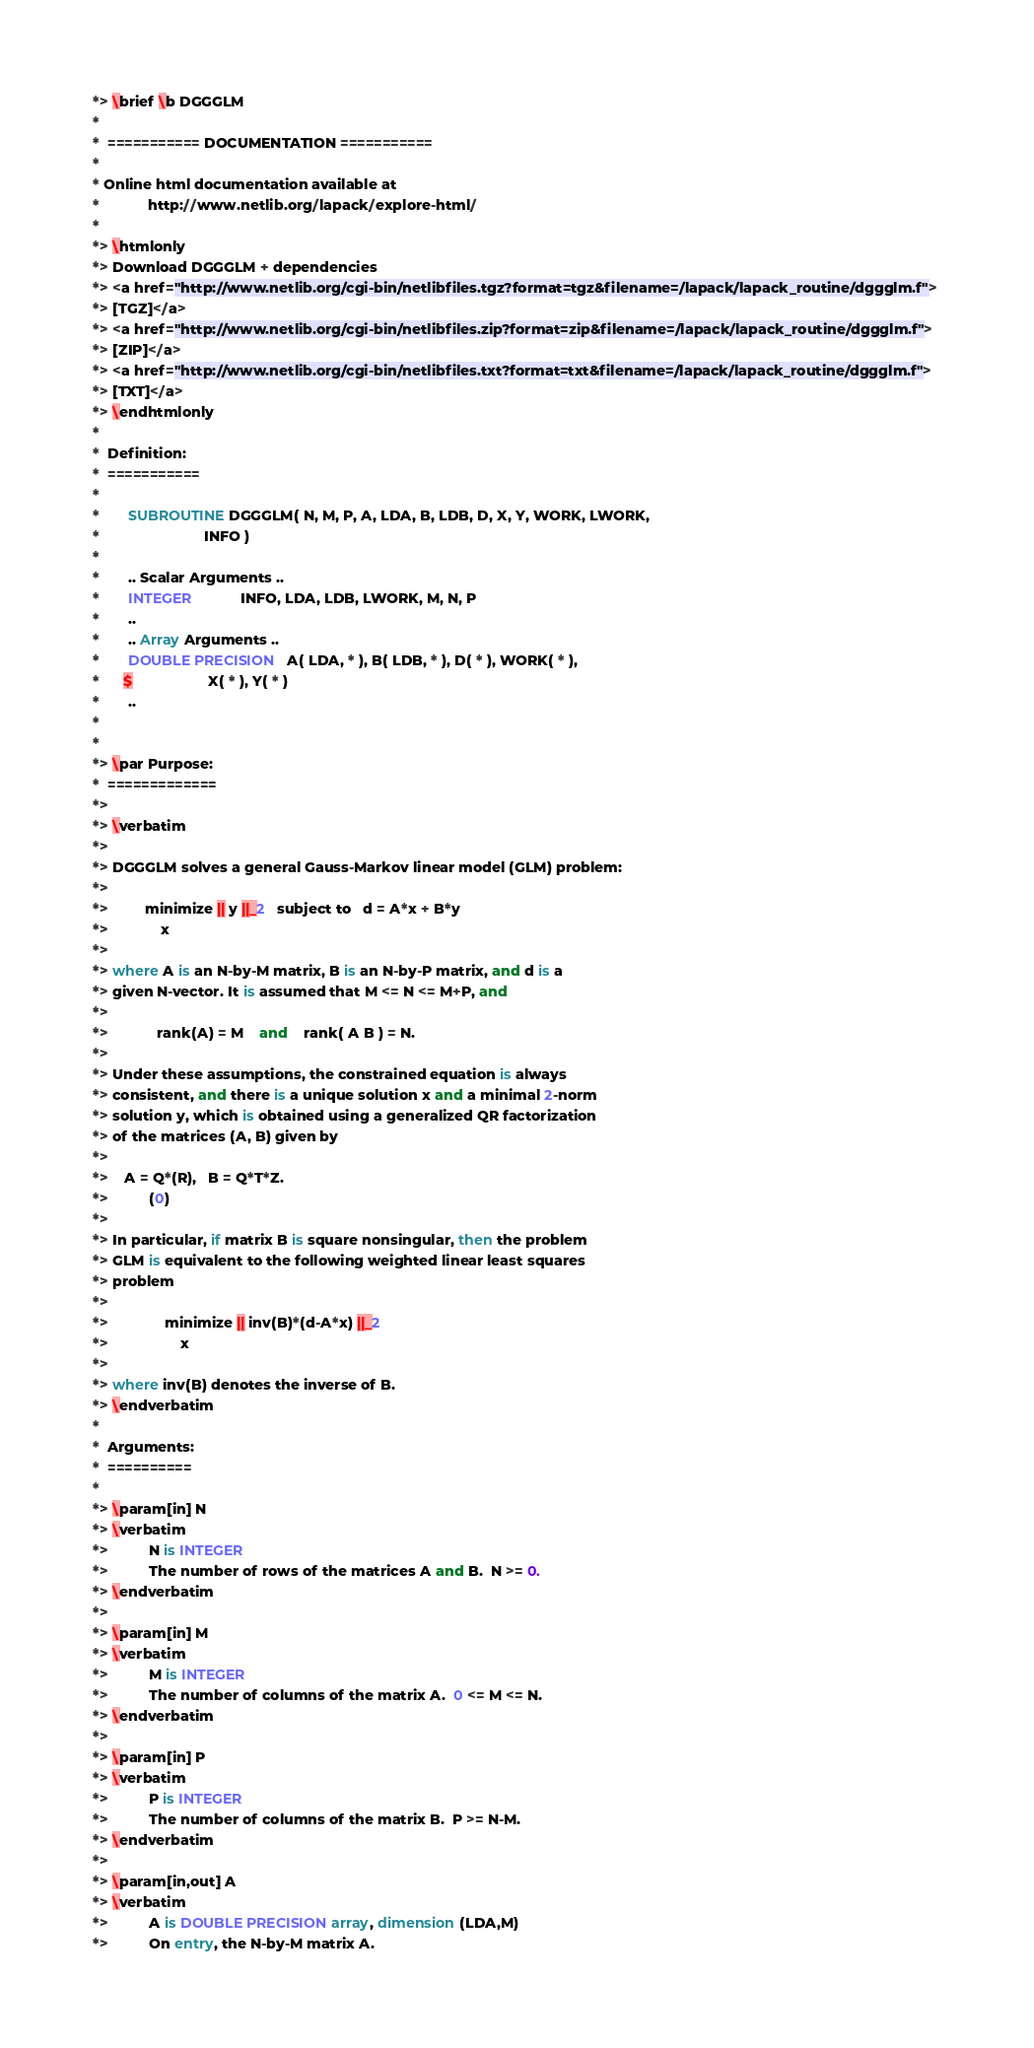<code> <loc_0><loc_0><loc_500><loc_500><_FORTRAN_>*> \brief \b DGGGLM
*
*  =========== DOCUMENTATION ===========
*
* Online html documentation available at 
*            http://www.netlib.org/lapack/explore-html/ 
*
*> \htmlonly
*> Download DGGGLM + dependencies 
*> <a href="http://www.netlib.org/cgi-bin/netlibfiles.tgz?format=tgz&filename=/lapack/lapack_routine/dggglm.f"> 
*> [TGZ]</a> 
*> <a href="http://www.netlib.org/cgi-bin/netlibfiles.zip?format=zip&filename=/lapack/lapack_routine/dggglm.f"> 
*> [ZIP]</a> 
*> <a href="http://www.netlib.org/cgi-bin/netlibfiles.txt?format=txt&filename=/lapack/lapack_routine/dggglm.f"> 
*> [TXT]</a>
*> \endhtmlonly 
*
*  Definition:
*  ===========
*
*       SUBROUTINE DGGGLM( N, M, P, A, LDA, B, LDB, D, X, Y, WORK, LWORK,
*                          INFO )
* 
*       .. Scalar Arguments ..
*       INTEGER            INFO, LDA, LDB, LWORK, M, N, P
*       ..
*       .. Array Arguments ..
*       DOUBLE PRECISION   A( LDA, * ), B( LDB, * ), D( * ), WORK( * ),
*      $                   X( * ), Y( * )
*       ..
*  
*
*> \par Purpose:
*  =============
*>
*> \verbatim
*>
*> DGGGLM solves a general Gauss-Markov linear model (GLM) problem:
*>
*>         minimize || y ||_2   subject to   d = A*x + B*y
*>             x
*>
*> where A is an N-by-M matrix, B is an N-by-P matrix, and d is a
*> given N-vector. It is assumed that M <= N <= M+P, and
*>
*>            rank(A) = M    and    rank( A B ) = N.
*>
*> Under these assumptions, the constrained equation is always
*> consistent, and there is a unique solution x and a minimal 2-norm
*> solution y, which is obtained using a generalized QR factorization
*> of the matrices (A, B) given by
*>
*>    A = Q*(R),   B = Q*T*Z.
*>          (0)
*>
*> In particular, if matrix B is square nonsingular, then the problem
*> GLM is equivalent to the following weighted linear least squares
*> problem
*>
*>              minimize || inv(B)*(d-A*x) ||_2
*>                  x
*>
*> where inv(B) denotes the inverse of B.
*> \endverbatim
*
*  Arguments:
*  ==========
*
*> \param[in] N
*> \verbatim
*>          N is INTEGER
*>          The number of rows of the matrices A and B.  N >= 0.
*> \endverbatim
*>
*> \param[in] M
*> \verbatim
*>          M is INTEGER
*>          The number of columns of the matrix A.  0 <= M <= N.
*> \endverbatim
*>
*> \param[in] P
*> \verbatim
*>          P is INTEGER
*>          The number of columns of the matrix B.  P >= N-M.
*> \endverbatim
*>
*> \param[in,out] A
*> \verbatim
*>          A is DOUBLE PRECISION array, dimension (LDA,M)
*>          On entry, the N-by-M matrix A.</code> 